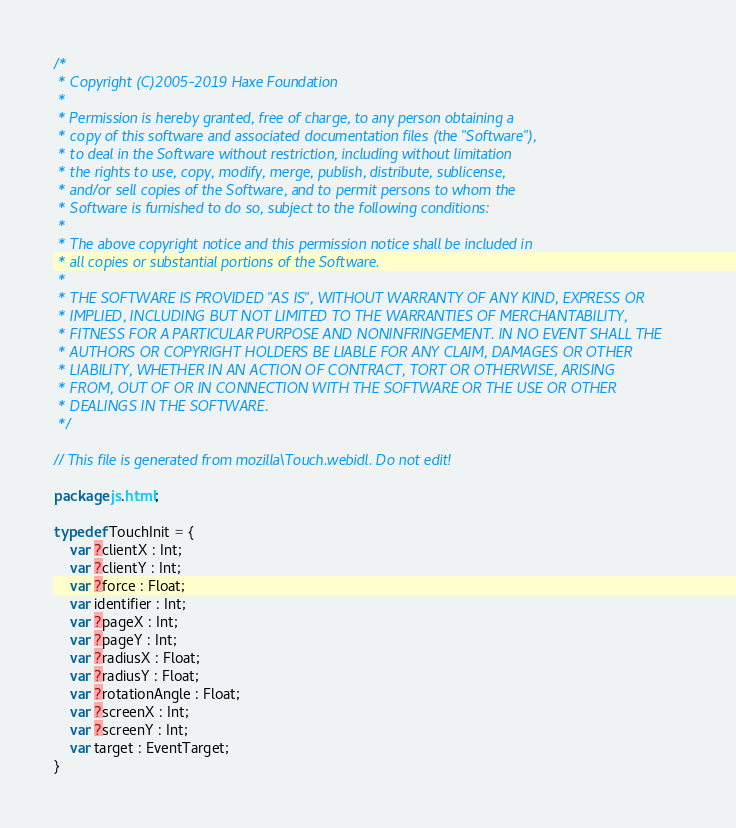<code> <loc_0><loc_0><loc_500><loc_500><_Haxe_>/*
 * Copyright (C)2005-2019 Haxe Foundation
 *
 * Permission is hereby granted, free of charge, to any person obtaining a
 * copy of this software and associated documentation files (the "Software"),
 * to deal in the Software without restriction, including without limitation
 * the rights to use, copy, modify, merge, publish, distribute, sublicense,
 * and/or sell copies of the Software, and to permit persons to whom the
 * Software is furnished to do so, subject to the following conditions:
 *
 * The above copyright notice and this permission notice shall be included in
 * all copies or substantial portions of the Software.
 *
 * THE SOFTWARE IS PROVIDED "AS IS", WITHOUT WARRANTY OF ANY KIND, EXPRESS OR
 * IMPLIED, INCLUDING BUT NOT LIMITED TO THE WARRANTIES OF MERCHANTABILITY,
 * FITNESS FOR A PARTICULAR PURPOSE AND NONINFRINGEMENT. IN NO EVENT SHALL THE
 * AUTHORS OR COPYRIGHT HOLDERS BE LIABLE FOR ANY CLAIM, DAMAGES OR OTHER
 * LIABILITY, WHETHER IN AN ACTION OF CONTRACT, TORT OR OTHERWISE, ARISING
 * FROM, OUT OF OR IN CONNECTION WITH THE SOFTWARE OR THE USE OR OTHER
 * DEALINGS IN THE SOFTWARE.
 */

// This file is generated from mozilla\Touch.webidl. Do not edit!

package js.html;

typedef TouchInit = {
	var ?clientX : Int;
	var ?clientY : Int;
	var ?force : Float;
	var identifier : Int;
	var ?pageX : Int;
	var ?pageY : Int;
	var ?radiusX : Float;
	var ?radiusY : Float;
	var ?rotationAngle : Float;
	var ?screenX : Int;
	var ?screenY : Int;
	var target : EventTarget;
}</code> 